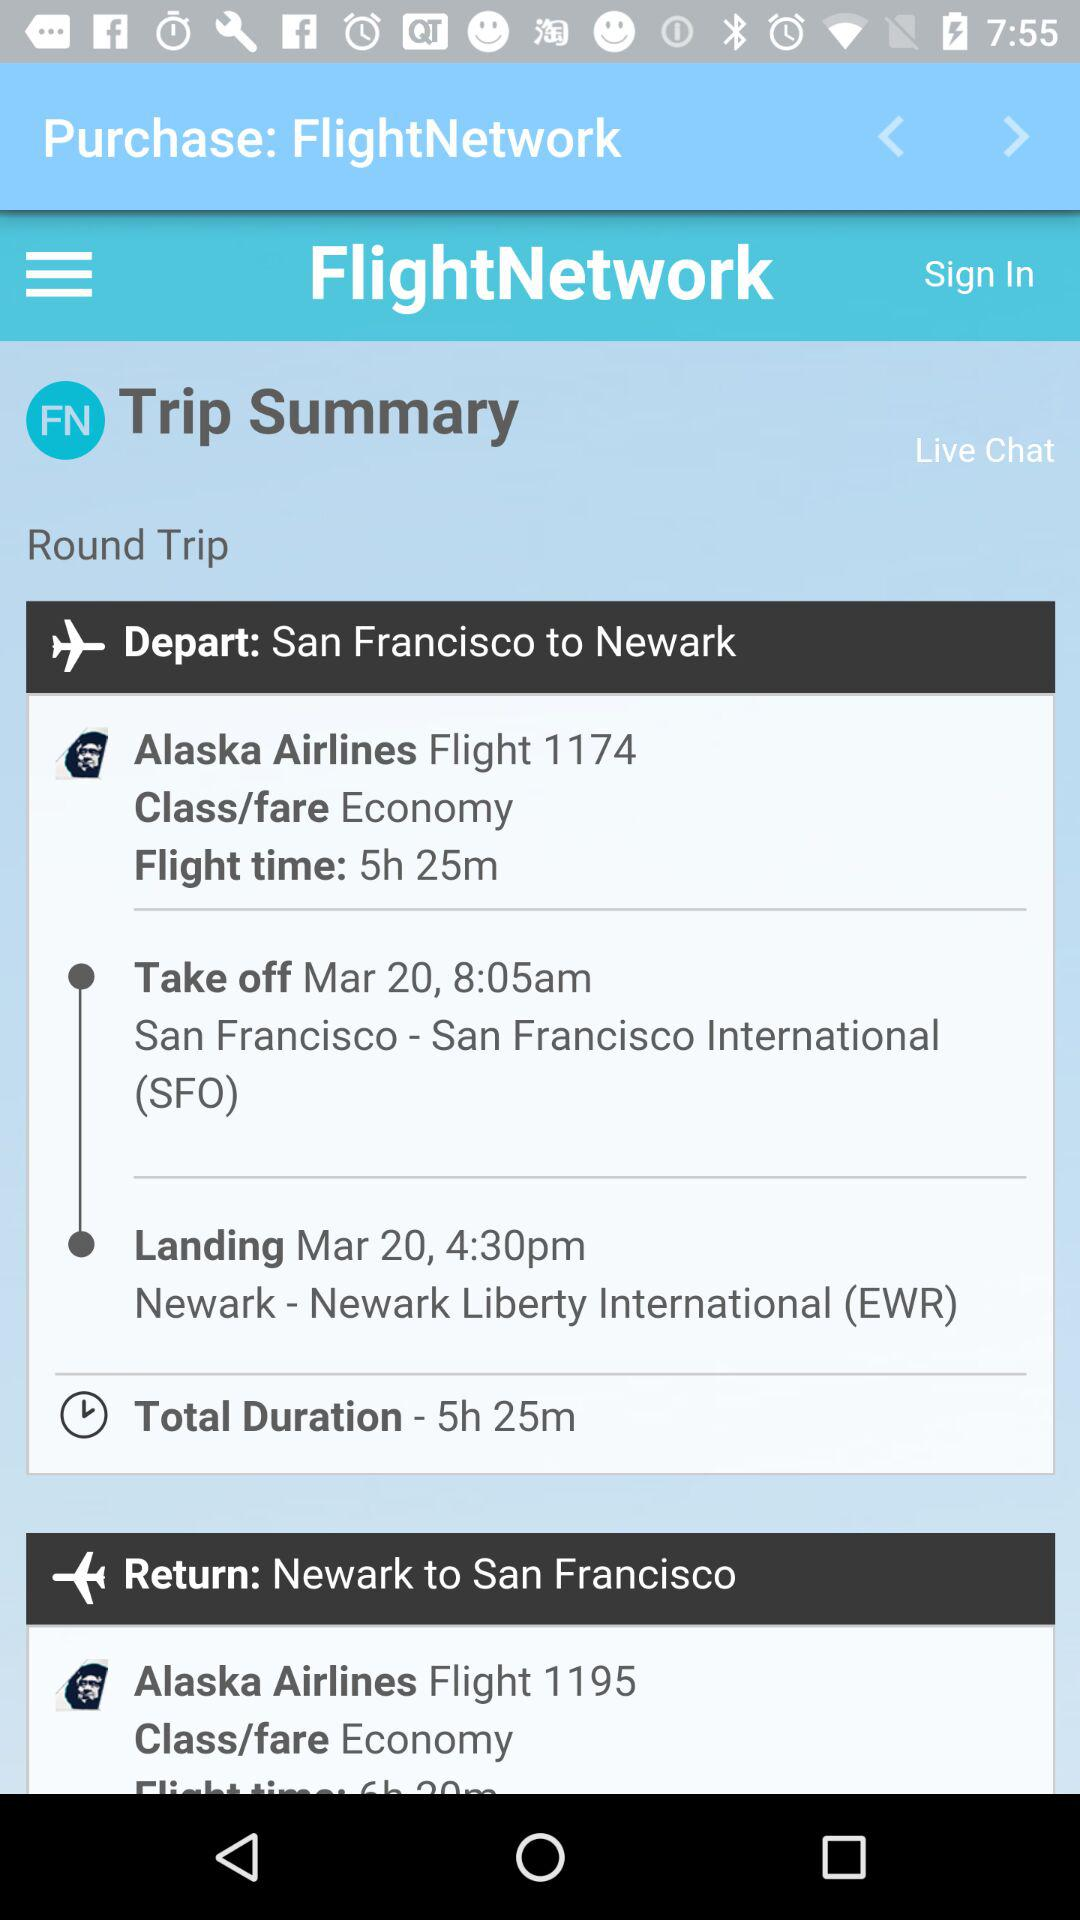What is the departure city for the return flight?
Answer the question using a single word or phrase. Newark 